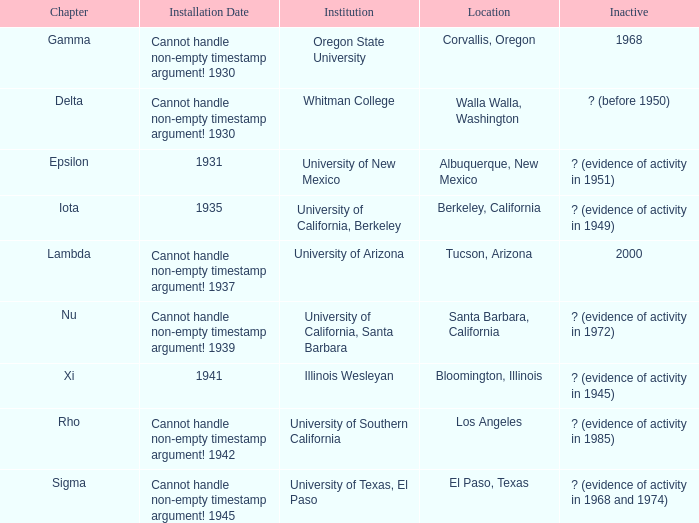What is the installation date for the Delta Chapter? Cannot handle non-empty timestamp argument! 1930. 